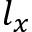<formula> <loc_0><loc_0><loc_500><loc_500>l _ { x }</formula> 